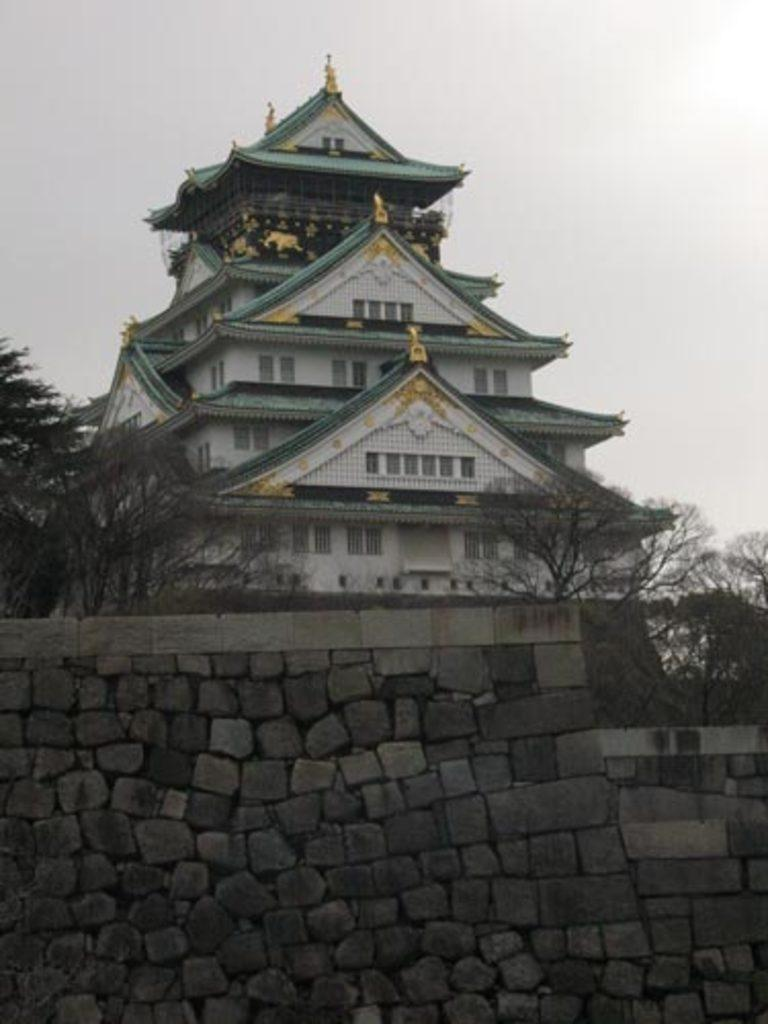What is the main structure in the center of the image? There is a building in the center of the image. What type of barrier is present at the bottom of the image? There is a stone wall at the bottom of the image. What type of vegetation can be seen in the image? There are trees in the image. What is visible in the background of the image? The sky is visible in the background of the image. How many hands are visible holding the trees in the image? There are no hands visible holding the trees in the image. Is there an island in the background of the image? There is no island present in the image; it features a building, stone wall, trees, and sky. 